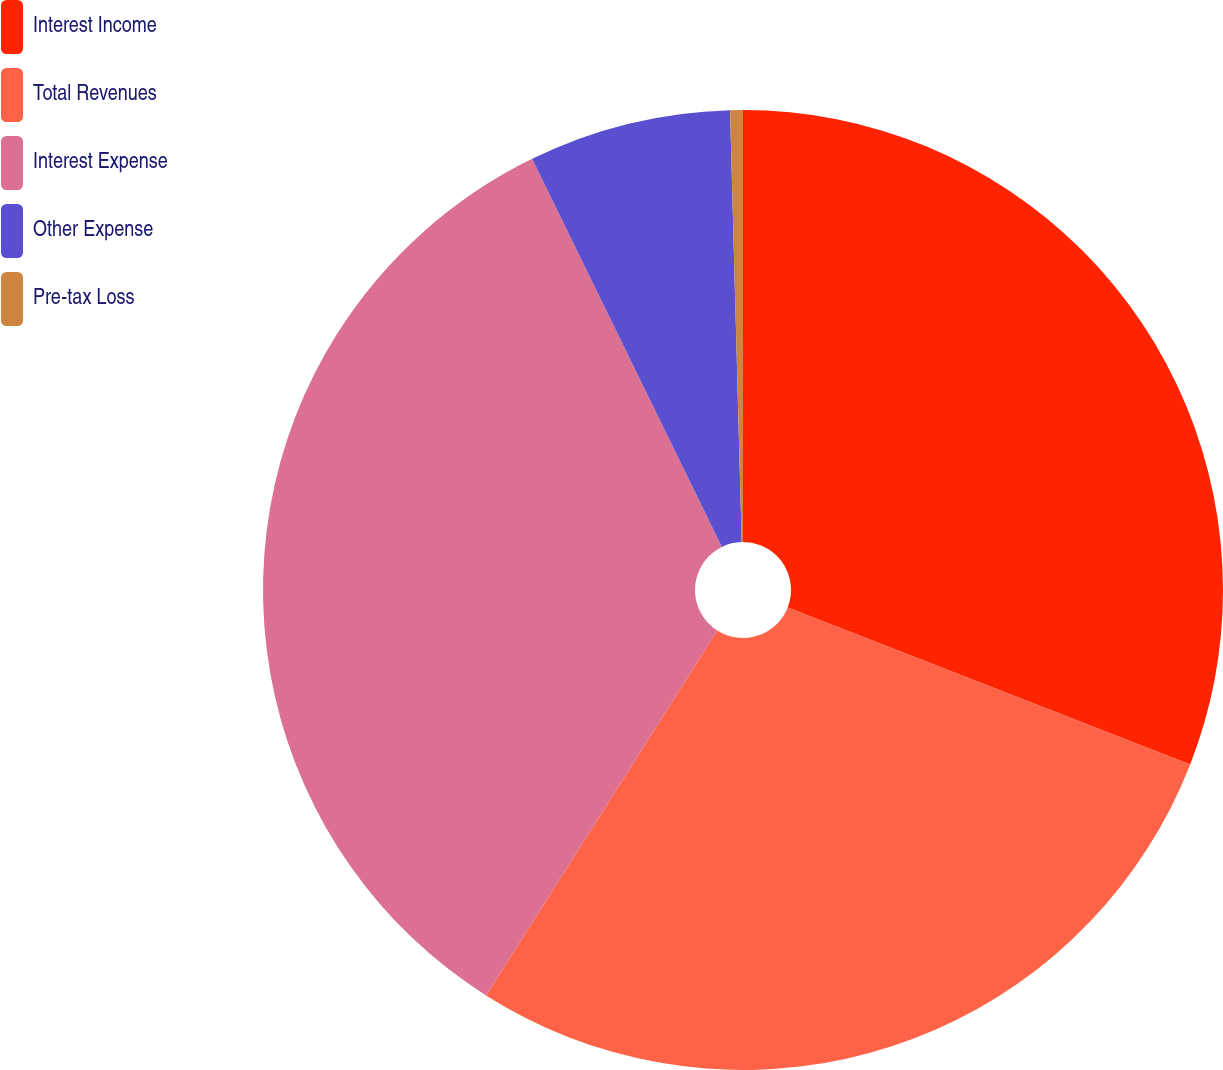Convert chart to OTSL. <chart><loc_0><loc_0><loc_500><loc_500><pie_chart><fcel>Interest Income<fcel>Total Revenues<fcel>Interest Expense<fcel>Other Expense<fcel>Pre-tax Loss<nl><fcel>30.92%<fcel>28.07%<fcel>33.77%<fcel>6.81%<fcel>0.43%<nl></chart> 